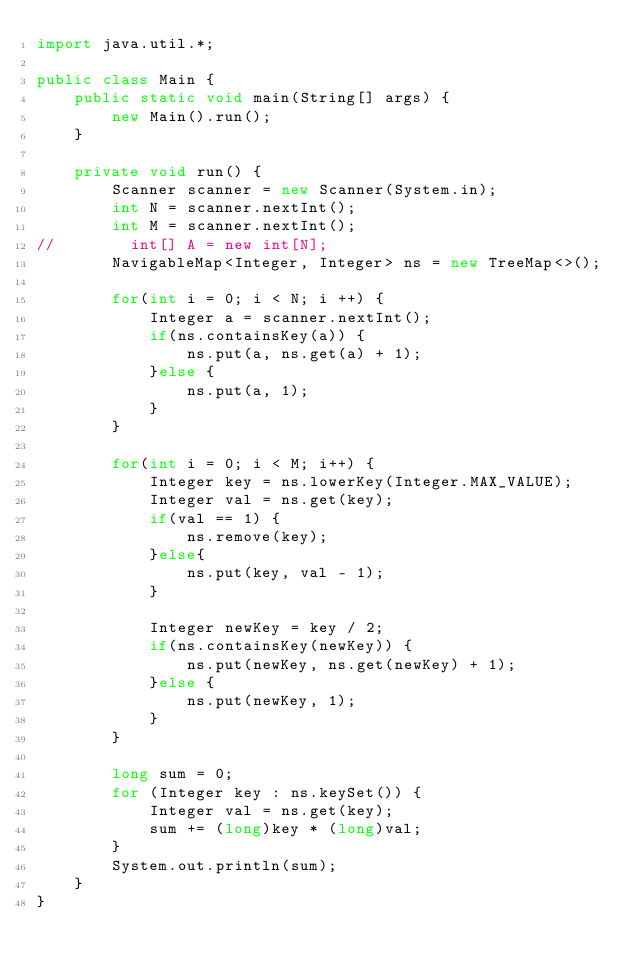Convert code to text. <code><loc_0><loc_0><loc_500><loc_500><_Java_>import java.util.*;

public class Main {
    public static void main(String[] args) {
        new Main().run();
    }

    private void run() {
        Scanner scanner = new Scanner(System.in);
        int N = scanner.nextInt();
        int M = scanner.nextInt();
//        int[] A = new int[N];
        NavigableMap<Integer, Integer> ns = new TreeMap<>();

        for(int i = 0; i < N; i ++) {
            Integer a = scanner.nextInt();
            if(ns.containsKey(a)) {
                ns.put(a, ns.get(a) + 1);
            }else {
                ns.put(a, 1);
            }
        }

        for(int i = 0; i < M; i++) {
            Integer key = ns.lowerKey(Integer.MAX_VALUE);
            Integer val = ns.get(key);
            if(val == 1) {
                ns.remove(key);
            }else{
                ns.put(key, val - 1);
            }

            Integer newKey = key / 2;
            if(ns.containsKey(newKey)) {
                ns.put(newKey, ns.get(newKey) + 1);
            }else {
                ns.put(newKey, 1);
            }
        }

        long sum = 0;
        for (Integer key : ns.keySet()) {
            Integer val = ns.get(key);
            sum += (long)key * (long)val;
        }
        System.out.println(sum);
    }
}
</code> 